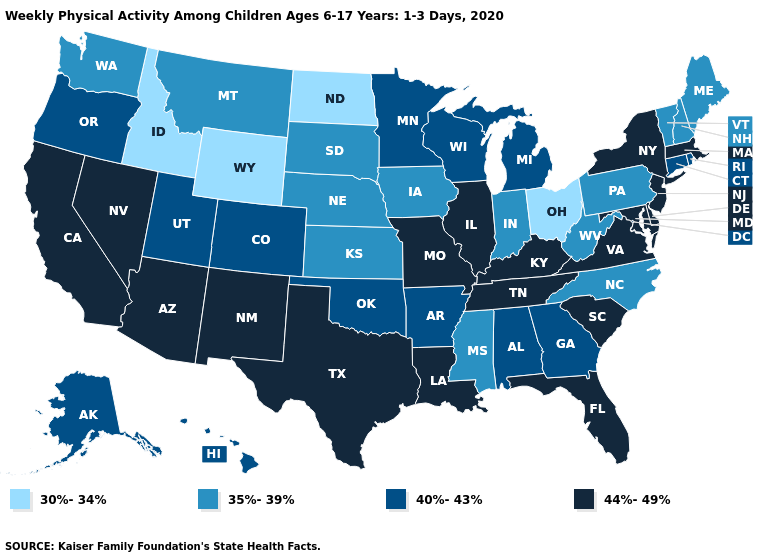Name the states that have a value in the range 44%-49%?
Keep it brief. Arizona, California, Delaware, Florida, Illinois, Kentucky, Louisiana, Maryland, Massachusetts, Missouri, Nevada, New Jersey, New Mexico, New York, South Carolina, Tennessee, Texas, Virginia. Does Ohio have the lowest value in the USA?
Short answer required. Yes. Which states hav the highest value in the MidWest?
Write a very short answer. Illinois, Missouri. Is the legend a continuous bar?
Give a very brief answer. No. What is the highest value in the MidWest ?
Concise answer only. 44%-49%. What is the value of Louisiana?
Be succinct. 44%-49%. Among the states that border Nevada , does Idaho have the lowest value?
Short answer required. Yes. Among the states that border Colorado , does Wyoming have the lowest value?
Concise answer only. Yes. How many symbols are there in the legend?
Give a very brief answer. 4. Among the states that border South Carolina , which have the highest value?
Quick response, please. Georgia. Name the states that have a value in the range 40%-43%?
Be succinct. Alabama, Alaska, Arkansas, Colorado, Connecticut, Georgia, Hawaii, Michigan, Minnesota, Oklahoma, Oregon, Rhode Island, Utah, Wisconsin. Which states hav the highest value in the West?
Answer briefly. Arizona, California, Nevada, New Mexico. How many symbols are there in the legend?
Quick response, please. 4. Which states hav the highest value in the Northeast?
Short answer required. Massachusetts, New Jersey, New York. What is the value of Delaware?
Short answer required. 44%-49%. 